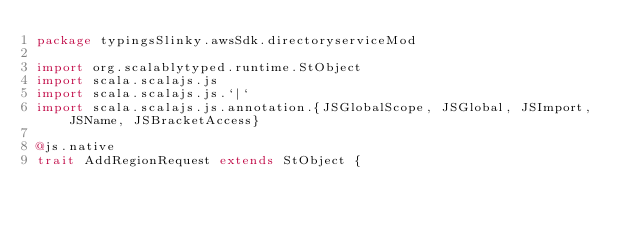<code> <loc_0><loc_0><loc_500><loc_500><_Scala_>package typingsSlinky.awsSdk.directoryserviceMod

import org.scalablytyped.runtime.StObject
import scala.scalajs.js
import scala.scalajs.js.`|`
import scala.scalajs.js.annotation.{JSGlobalScope, JSGlobal, JSImport, JSName, JSBracketAccess}

@js.native
trait AddRegionRequest extends StObject {</code> 